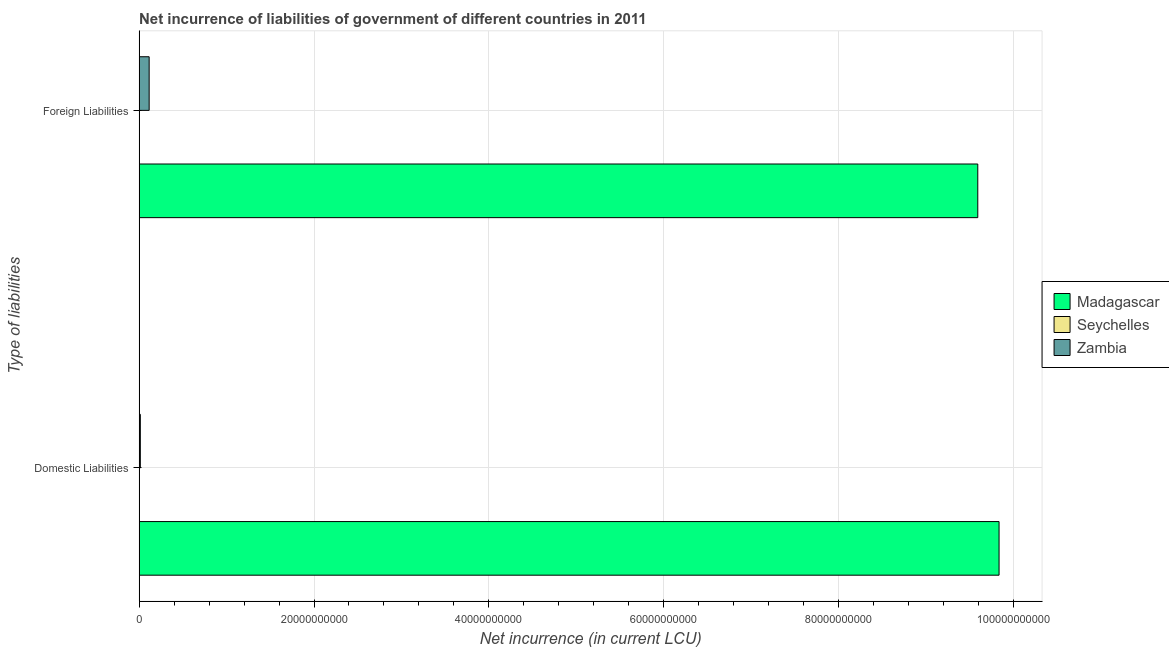How many different coloured bars are there?
Offer a terse response. 2. Are the number of bars per tick equal to the number of legend labels?
Your answer should be very brief. No. Are the number of bars on each tick of the Y-axis equal?
Offer a terse response. Yes. How many bars are there on the 2nd tick from the bottom?
Ensure brevity in your answer.  2. What is the label of the 2nd group of bars from the top?
Keep it short and to the point. Domestic Liabilities. What is the net incurrence of foreign liabilities in Zambia?
Ensure brevity in your answer.  1.15e+09. Across all countries, what is the maximum net incurrence of domestic liabilities?
Ensure brevity in your answer.  9.83e+1. In which country was the net incurrence of domestic liabilities maximum?
Offer a very short reply. Madagascar. What is the total net incurrence of foreign liabilities in the graph?
Provide a succinct answer. 9.71e+1. What is the difference between the net incurrence of foreign liabilities in Madagascar and that in Zambia?
Ensure brevity in your answer.  9.47e+1. What is the difference between the net incurrence of domestic liabilities in Zambia and the net incurrence of foreign liabilities in Madagascar?
Ensure brevity in your answer.  -9.58e+1. What is the average net incurrence of domestic liabilities per country?
Offer a terse response. 3.28e+1. What is the difference between the net incurrence of domestic liabilities and net incurrence of foreign liabilities in Madagascar?
Your response must be concise. 2.43e+09. In how many countries, is the net incurrence of domestic liabilities greater than the average net incurrence of domestic liabilities taken over all countries?
Provide a short and direct response. 1. How many bars are there?
Give a very brief answer. 4. How many countries are there in the graph?
Keep it short and to the point. 3. What is the difference between two consecutive major ticks on the X-axis?
Your response must be concise. 2.00e+1. Where does the legend appear in the graph?
Your response must be concise. Center right. How many legend labels are there?
Your answer should be compact. 3. How are the legend labels stacked?
Your answer should be very brief. Vertical. What is the title of the graph?
Your answer should be very brief. Net incurrence of liabilities of government of different countries in 2011. What is the label or title of the X-axis?
Your answer should be compact. Net incurrence (in current LCU). What is the label or title of the Y-axis?
Your answer should be compact. Type of liabilities. What is the Net incurrence (in current LCU) of Madagascar in Domestic Liabilities?
Offer a terse response. 9.83e+1. What is the Net incurrence (in current LCU) in Seychelles in Domestic Liabilities?
Give a very brief answer. 0. What is the Net incurrence (in current LCU) of Zambia in Domestic Liabilities?
Your answer should be compact. 1.40e+08. What is the Net incurrence (in current LCU) in Madagascar in Foreign Liabilities?
Your response must be concise. 9.59e+1. What is the Net incurrence (in current LCU) of Seychelles in Foreign Liabilities?
Make the answer very short. 0. What is the Net incurrence (in current LCU) of Zambia in Foreign Liabilities?
Ensure brevity in your answer.  1.15e+09. Across all Type of liabilities, what is the maximum Net incurrence (in current LCU) in Madagascar?
Keep it short and to the point. 9.83e+1. Across all Type of liabilities, what is the maximum Net incurrence (in current LCU) in Zambia?
Your answer should be very brief. 1.15e+09. Across all Type of liabilities, what is the minimum Net incurrence (in current LCU) of Madagascar?
Provide a short and direct response. 9.59e+1. Across all Type of liabilities, what is the minimum Net incurrence (in current LCU) of Zambia?
Ensure brevity in your answer.  1.40e+08. What is the total Net incurrence (in current LCU) in Madagascar in the graph?
Provide a short and direct response. 1.94e+11. What is the total Net incurrence (in current LCU) of Seychelles in the graph?
Make the answer very short. 0. What is the total Net incurrence (in current LCU) of Zambia in the graph?
Your answer should be very brief. 1.29e+09. What is the difference between the Net incurrence (in current LCU) in Madagascar in Domestic Liabilities and that in Foreign Liabilities?
Make the answer very short. 2.43e+09. What is the difference between the Net incurrence (in current LCU) in Zambia in Domestic Liabilities and that in Foreign Liabilities?
Give a very brief answer. -1.01e+09. What is the difference between the Net incurrence (in current LCU) in Madagascar in Domestic Liabilities and the Net incurrence (in current LCU) in Zambia in Foreign Liabilities?
Make the answer very short. 9.72e+1. What is the average Net incurrence (in current LCU) of Madagascar per Type of liabilities?
Ensure brevity in your answer.  9.71e+1. What is the average Net incurrence (in current LCU) in Seychelles per Type of liabilities?
Give a very brief answer. 0. What is the average Net incurrence (in current LCU) of Zambia per Type of liabilities?
Make the answer very short. 6.45e+08. What is the difference between the Net incurrence (in current LCU) in Madagascar and Net incurrence (in current LCU) in Zambia in Domestic Liabilities?
Your response must be concise. 9.82e+1. What is the difference between the Net incurrence (in current LCU) in Madagascar and Net incurrence (in current LCU) in Zambia in Foreign Liabilities?
Ensure brevity in your answer.  9.47e+1. What is the ratio of the Net incurrence (in current LCU) of Madagascar in Domestic Liabilities to that in Foreign Liabilities?
Your response must be concise. 1.03. What is the ratio of the Net incurrence (in current LCU) of Zambia in Domestic Liabilities to that in Foreign Liabilities?
Provide a short and direct response. 0.12. What is the difference between the highest and the second highest Net incurrence (in current LCU) in Madagascar?
Offer a terse response. 2.43e+09. What is the difference between the highest and the second highest Net incurrence (in current LCU) in Zambia?
Offer a very short reply. 1.01e+09. What is the difference between the highest and the lowest Net incurrence (in current LCU) of Madagascar?
Your answer should be very brief. 2.43e+09. What is the difference between the highest and the lowest Net incurrence (in current LCU) of Zambia?
Provide a short and direct response. 1.01e+09. 